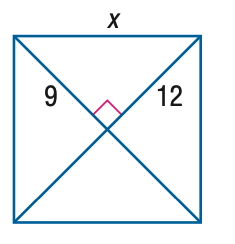Answer the mathemtical geometry problem and directly provide the correct option letter.
Question: Find x.
Choices: A: 13 B: 14 C: 15 D: 16 C 